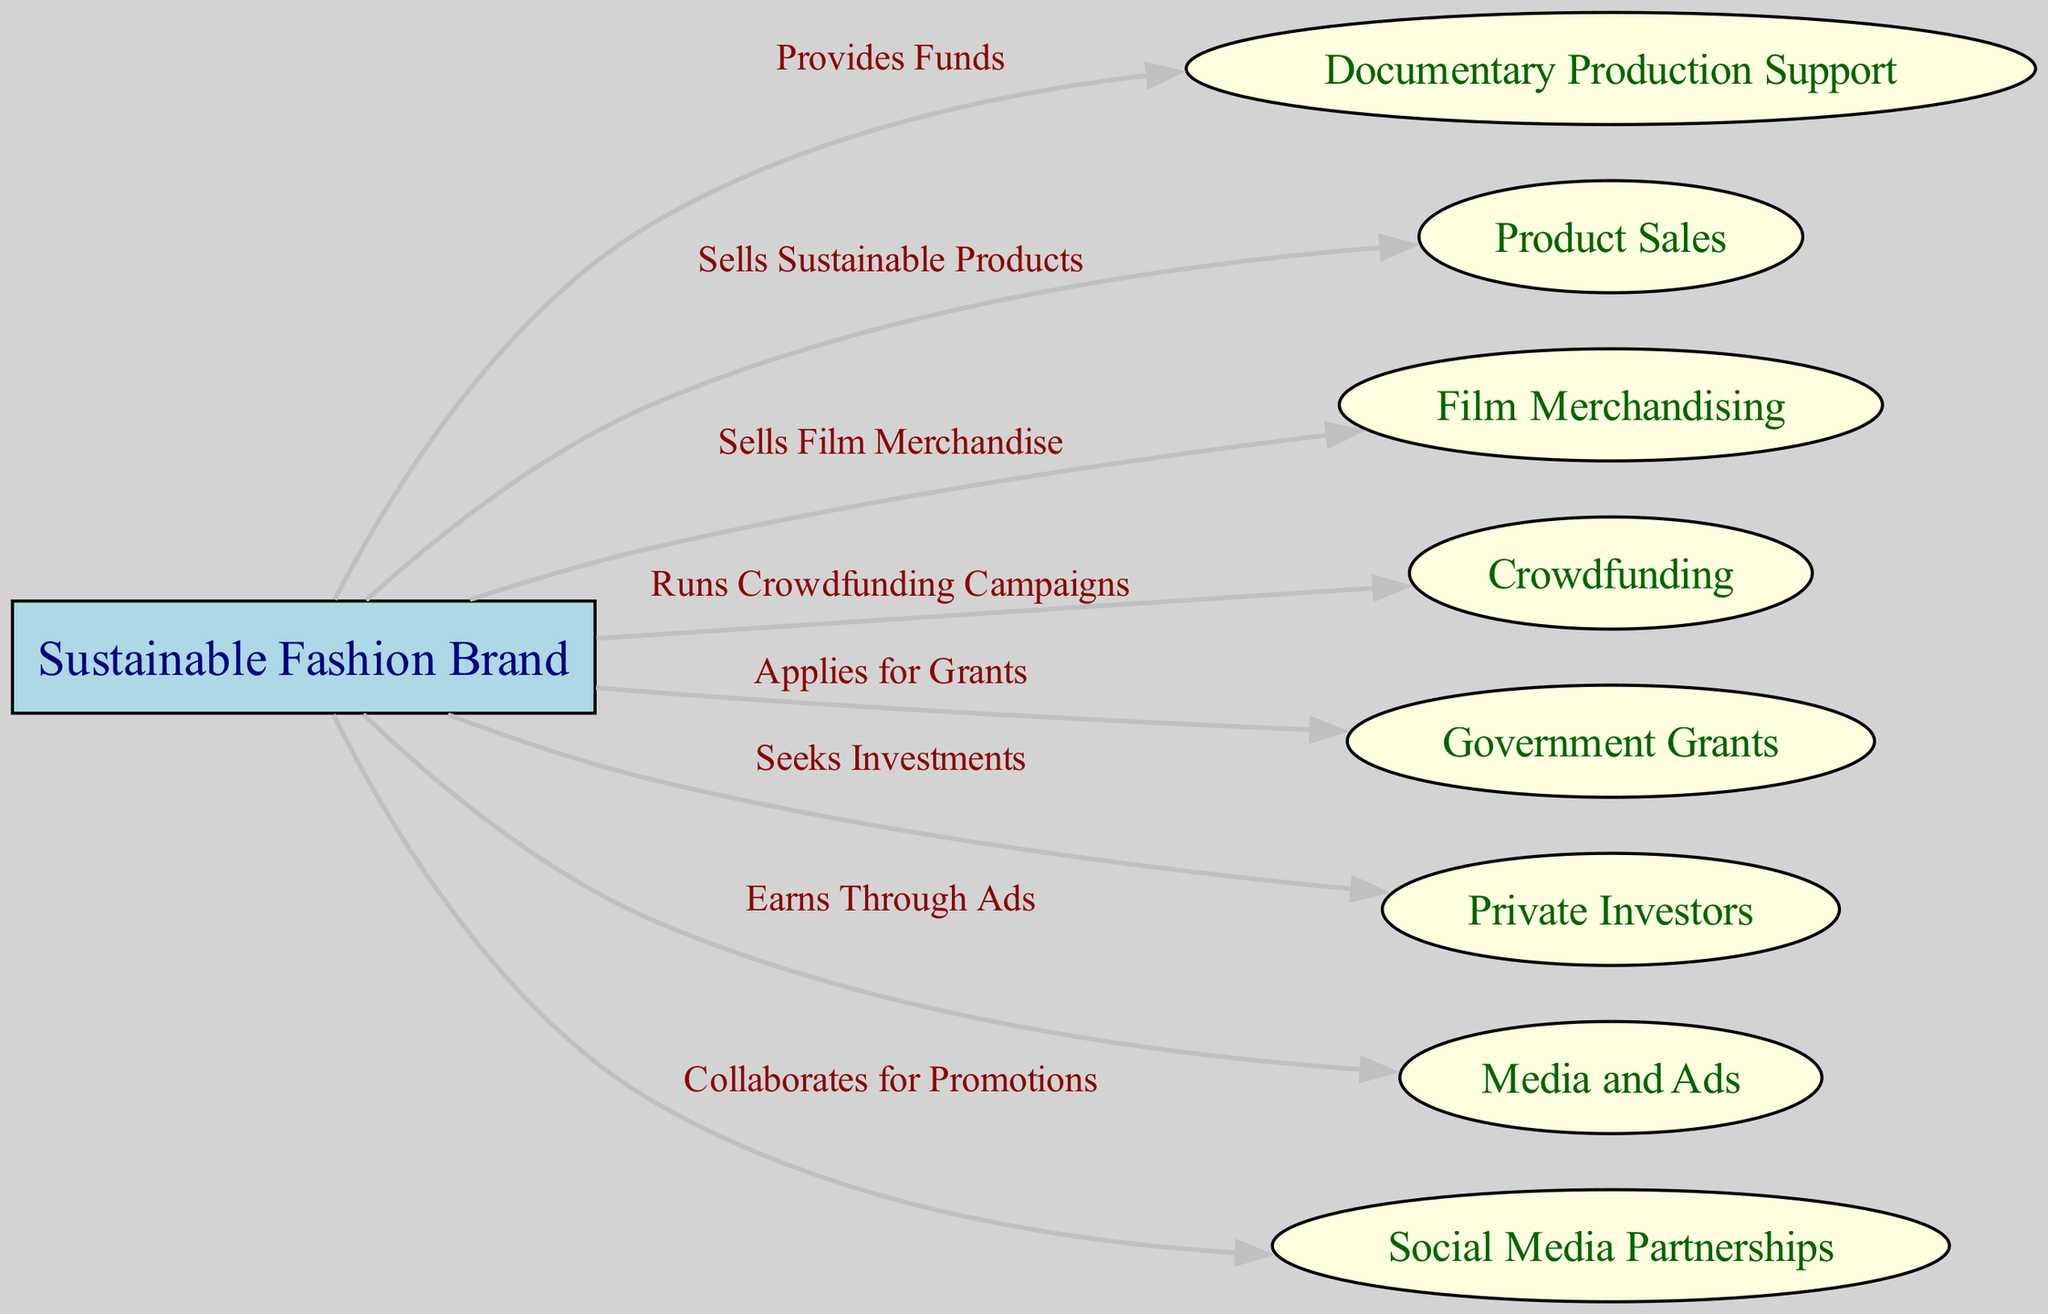What is the primary function of the Sustainable Fashion Brand in the diagram? The diagram indicates that the primary function of the Sustainable Fashion Brand is to provide funds for documentary productions, as shown through the directed edge labeled "Provides Funds."
Answer: Provides Funds How many total nodes are present in the diagram? By counting all the unique entities in the diagram, there are a total of eight nodes: one Sustainable Fashion Brand and seven revenue sources or connections.
Answer: 8 What type of node is the Sustainable Fashion Brand? The diagram specifies that the Sustainable Fashion Brand is represented as a box, indicating its role as a primary actor or source in the revenue stream.
Answer: Box Which revenue source directly involves the audience's financial engagement? The diagram illustrates that Crowdfunding directly involves audience financial engagement, as it shows a connection where the Sustainable Fashion Brand runs crowdfunding campaigns.
Answer: Crowdfunding What relationship exists between the Sustainable Fashion Brand and Media and Ads? The diagram demonstrates a direct edge indicating that the Sustainable Fashion Brand earns revenue through ads, suggesting a direct financial relationship in this direction.
Answer: Earns Through Ads How does the Sustainable Fashion Brand support documentary production? The diagram clearly indicates that the Sustainable Fashion Brand supports documentary production by providing funds, which is a key aspect of its operational strategy.
Answer: Provides Funds Which revenue source requires the involvement of third parties, such as individuals or organizations, for financial support? The diagram indicates that Private Investors as a revenue source require third-party involvement, as the brand seeks investments from them to support its activities.
Answer: Private Investors What is the purpose of applying for Government Grants in relation to the Sustainable Fashion Brand? The diagram specifies that the purpose of applying for Government Grants is to secure additional funding for projects or initiatives, enhancing the brand’s revenue streams.
Answer: Applies for Grants In terms of promotional strategies, what action does the Sustainable Fashion Brand take? The diagram shows that the Sustainable Fashion Brand collaborates for promotions with Social Media Partnerships, indicating a strategic promotional action within its operations.
Answer: Collaborates for Promotions 